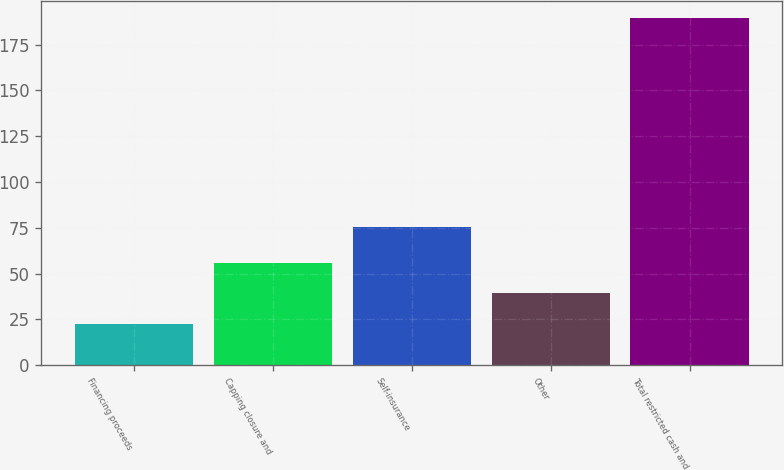Convert chart to OTSL. <chart><loc_0><loc_0><loc_500><loc_500><bar_chart><fcel>Financing proceeds<fcel>Capping closure and<fcel>Self-insurance<fcel>Other<fcel>Total restricted cash and<nl><fcel>22.5<fcel>55.92<fcel>75.2<fcel>39.21<fcel>189.6<nl></chart> 